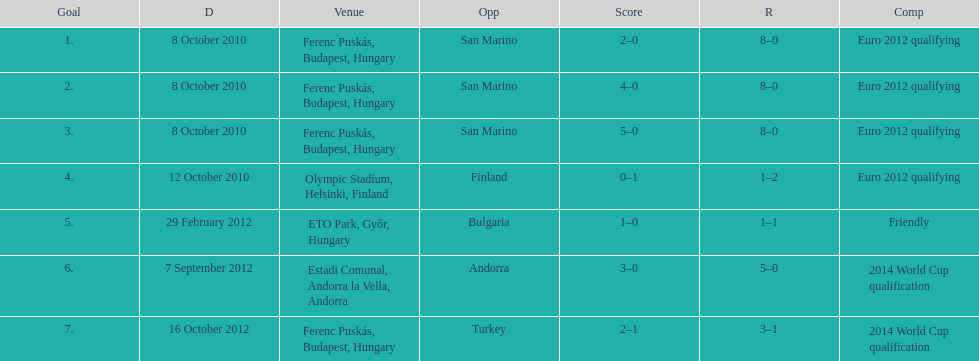In what year was szalai's first international goal? 2010. 